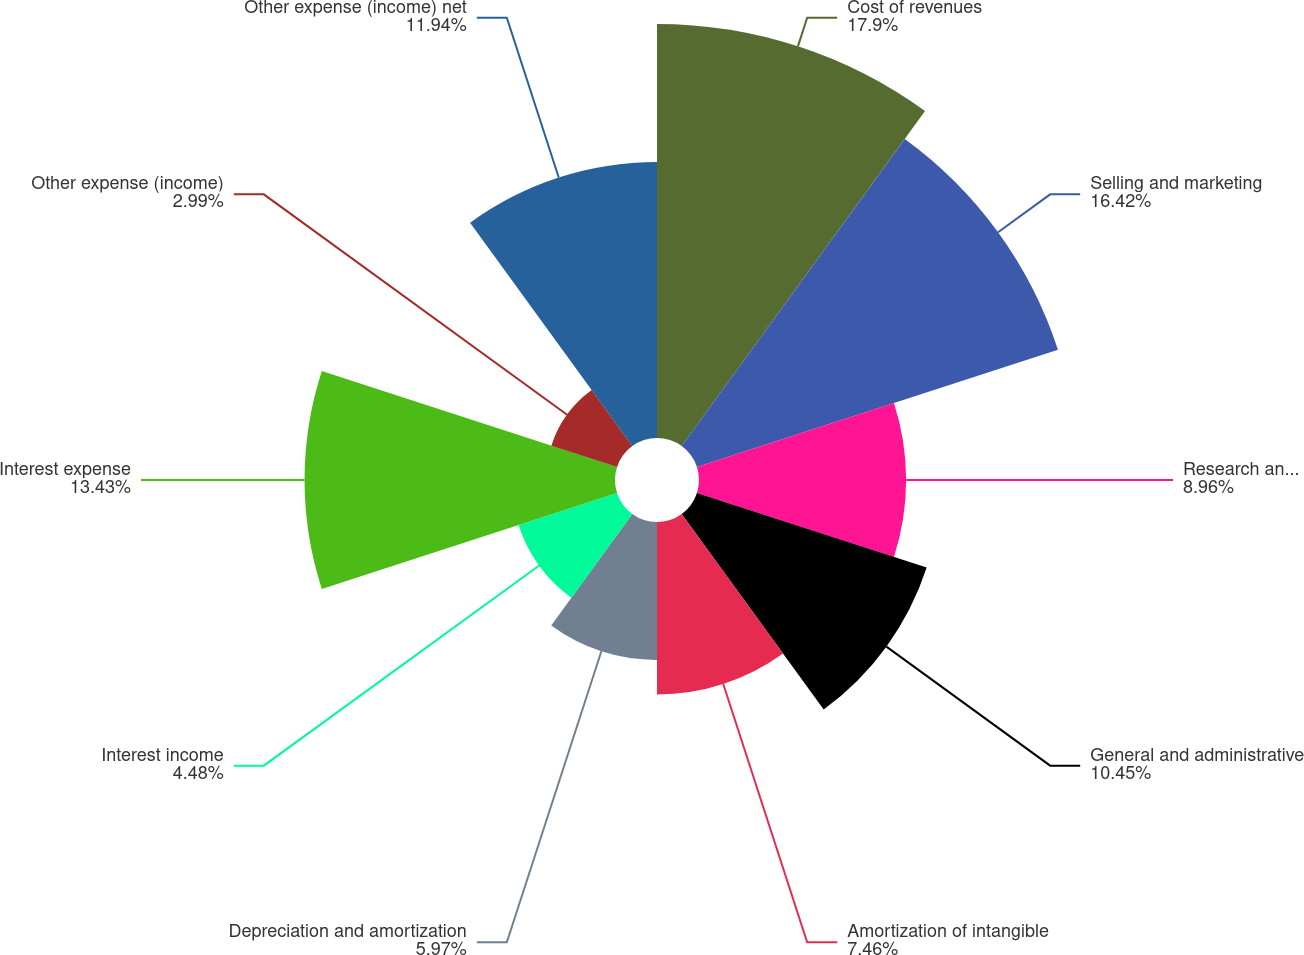<chart> <loc_0><loc_0><loc_500><loc_500><pie_chart><fcel>Cost of revenues<fcel>Selling and marketing<fcel>Research and development<fcel>General and administrative<fcel>Amortization of intangible<fcel>Depreciation and amortization<fcel>Interest income<fcel>Interest expense<fcel>Other expense (income)<fcel>Other expense (income) net<nl><fcel>17.91%<fcel>16.42%<fcel>8.96%<fcel>10.45%<fcel>7.46%<fcel>5.97%<fcel>4.48%<fcel>13.43%<fcel>2.99%<fcel>11.94%<nl></chart> 